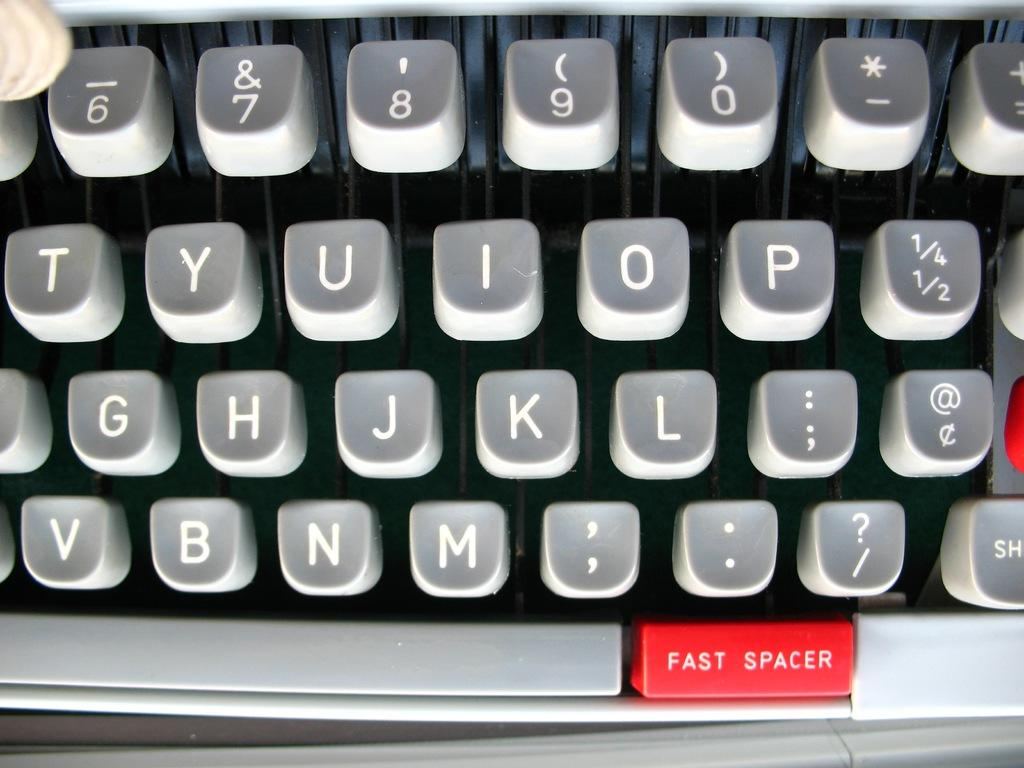<image>
Present a compact description of the photo's key features. A keyboard with a unique fast spacer key on it 